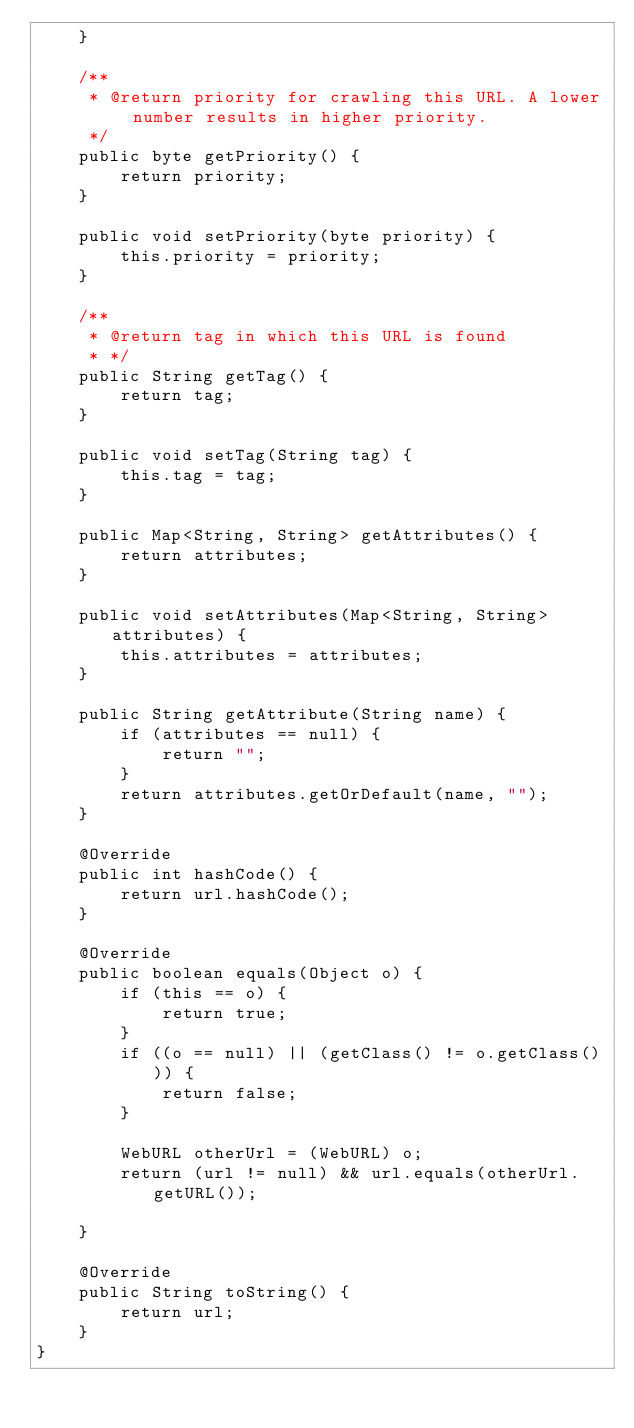<code> <loc_0><loc_0><loc_500><loc_500><_Java_>    }

    /**
     * @return priority for crawling this URL. A lower number results in higher priority.
     */
    public byte getPriority() {
        return priority;
    }

    public void setPriority(byte priority) {
        this.priority = priority;
    }

    /**
     * @return tag in which this URL is found
     * */
    public String getTag() {
        return tag;
    }

    public void setTag(String tag) {
        this.tag = tag;
    }

    public Map<String, String> getAttributes() {
        return attributes;
    }

    public void setAttributes(Map<String, String> attributes) {
        this.attributes = attributes;
    }

    public String getAttribute(String name) {
        if (attributes == null) {
            return "";
        }
        return attributes.getOrDefault(name, "");
    }

    @Override
    public int hashCode() {
        return url.hashCode();
    }

    @Override
    public boolean equals(Object o) {
        if (this == o) {
            return true;
        }
        if ((o == null) || (getClass() != o.getClass())) {
            return false;
        }

        WebURL otherUrl = (WebURL) o;
        return (url != null) && url.equals(otherUrl.getURL());

    }

    @Override
    public String toString() {
        return url;
    }
}</code> 